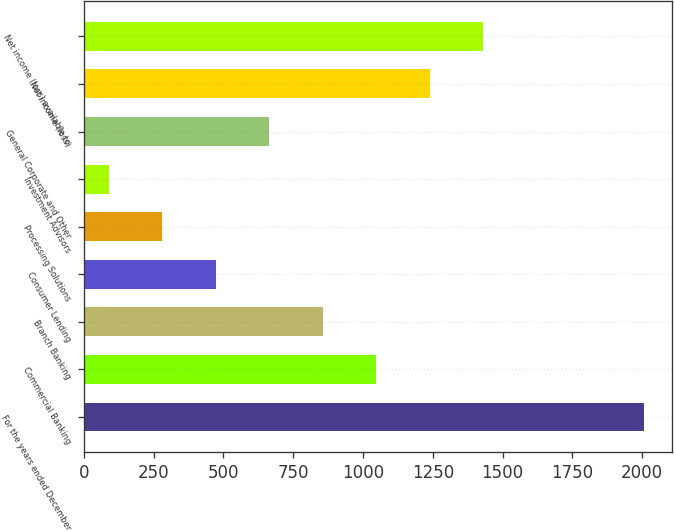Convert chart to OTSL. <chart><loc_0><loc_0><loc_500><loc_500><bar_chart><fcel>For the years ended December<fcel>Commercial Banking<fcel>Branch Banking<fcel>Consumer Lending<fcel>Processing Solutions<fcel>Investment Advisors<fcel>General Corporate and Other<fcel>Net income (loss)<fcel>Net income (loss) available to<nl><fcel>2006<fcel>1048<fcel>856.4<fcel>473.2<fcel>281.6<fcel>90<fcel>664.8<fcel>1239.6<fcel>1431.2<nl></chart> 